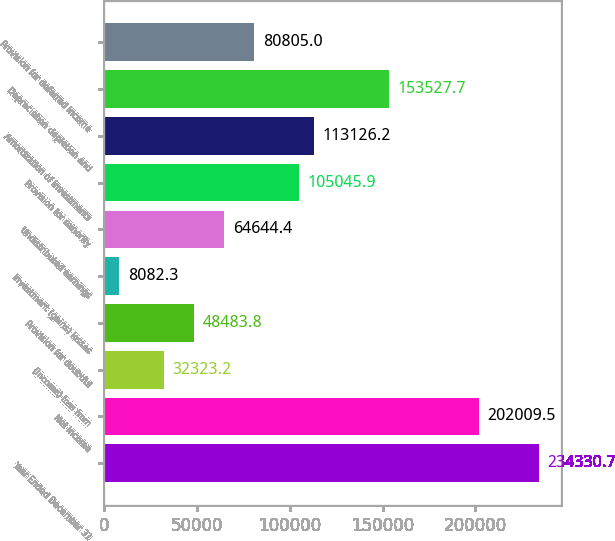Convert chart to OTSL. <chart><loc_0><loc_0><loc_500><loc_500><bar_chart><fcel>Year Ended December 31<fcel>Net income<fcel>(Income) loss from<fcel>Provision for doubtful<fcel>Investment (gains) losses<fcel>Undistributed earnings<fcel>Provision for minority<fcel>Amortization of investments<fcel>Depreciation depletion and<fcel>Provision for deferred income<nl><fcel>234331<fcel>202010<fcel>32323.2<fcel>48483.8<fcel>8082.3<fcel>64644.4<fcel>105046<fcel>113126<fcel>153528<fcel>80805<nl></chart> 